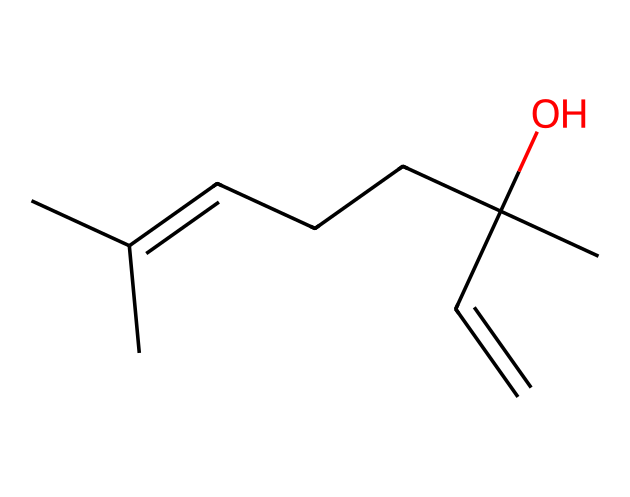What is the molecular formula of geraniol? To find the molecular formula, we count the carbon (C), hydrogen (H), and oxygen (O) atoms in the SMILES representation. There are 10 carbon atoms, 18 hydrogen atoms, and 1 oxygen atom, giving a molecular formula of C10H18O.
Answer: C10H18O How many double bonds are present in the structure? By analyzing the SMILES, we see a 'C=C' which indicates a double bond between two carbon atoms. Thus, there is one double bond present in the structure.
Answer: 1 What functional group characterizes geraniol? The structure shows a hydroxyl group (-OH) attached to a carbon atom, which is characteristic of alcohols. Therefore, the functional group of geraniol is an alcohol.
Answer: alcohol What type of isomerism can be observed in compounds related to geraniol? Geraniol can exhibit geometric isomerism due to the presence of a double bond (C=C) in the structure, which could lead to cis and trans forms.
Answer: geometric isomerism Does geraniol have a cyclic structure? The SMILES structure does not show any cyclic connectivity between carbon atoms; all connections are linear or branched. Thus, geraniol does not have a cyclic structure.
Answer: no How many chiral centers are present in geraniol? By analyzing the structure, there are two carbon atoms that are attached to four different groups, making them chiral centers. Thus, geraniol has two chiral centers.
Answer: 2 Is geraniol soluble in water? With its alcohol functional group, geraniol can form hydrogen bonds with water molecules, making it slightly soluble in water.
Answer: slightly soluble 